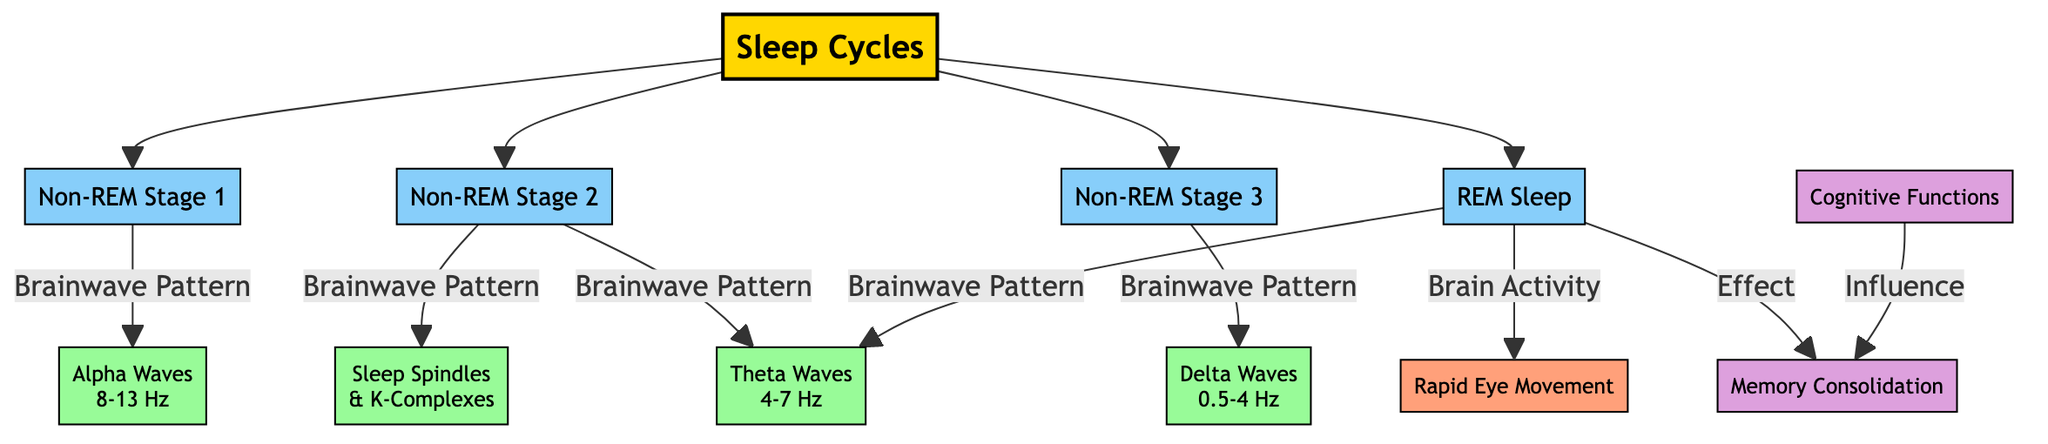What are the stages of sleep shown in the diagram? The diagram displays five stages of sleep: Non-REM Stage 1, Non-REM Stage 2, Non-REM Stage 3, Non-REM Stage 4, and REM Sleep. These stages are listed under the title "Sleep Cycles".
Answer: Non-REM Stage 1, Non-REM Stage 2, Non-REM Stage 3, Non-REM Stage 4, REM Sleep Which brainwave pattern is associated with Non-REM Stage 3? According to the diagram, Non-REM Stage 3 is linked to Delta Waves. This is indicated by the node connected to Non-REM Stage 3 labeled with "Brainwave Pattern".
Answer: Delta Waves How many types of brainwaves are mentioned in the diagram? The diagram includes four types of brainwaves: Alpha Waves, Theta Waves, Delta Waves, and Sleep Spindles/K-Complexes. By counting the nodes specifically for brainwave patterns, we identify these four distinct types.
Answer: 4 What effect does REM Sleep have according to the diagram? The diagram shows that REM Sleep has an effect on Memory Consolidation. This relationship is depicted with a directed connection from REM Sleep to Memory Consolidation labeled as "Effect".
Answer: Memory Consolidation What is the relationship between Cognitive Functions and Memory Consolidation? The diagram indicates that Cognitive Functions influence Memory Consolidation, as represented by a directed relationship from Cognitive Functions to Memory Consolidation labeled as "Influence".
Answer: Influence Which stage is associated with Sleep Spindles and K-Complexes? The diagram connects Sleep Spindles and K-Complexes to Non-REM Stage 2. This is detailed in the section of the diagram that notes the brainwave patterns corresponding to that stage.
Answer: Non-REM Stage 2 What type of brain activity is represented during REM Sleep? The diagram indicates that brain activity during REM Sleep is characterized by Rapid Eye Movement. This relationship is shown under the REM Sleep node with the label "Brain Activity".
Answer: Rapid Eye Movement How many total stages of sleep are depicted in the diagram? The diagram presents a total of five stages of sleep, listed as the various Non-REM and REM stages. Each of these stages is visually represented, allowing us to count them.
Answer: 5 What brainwave frequency range corresponds to Alpha Waves? Alpha Waves are represented as having a frequency range of 8-13 Hz in the diagram. This information is found in the node connected to Alpha Waves specifically detailing the frequency range.
Answer: 8-13 Hz 